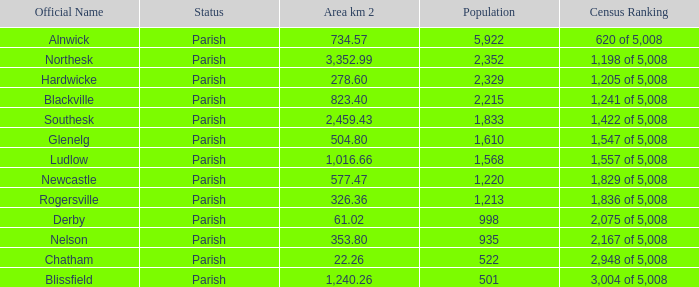Can you tell me the sum of Area km 2 that has the Official Name of glenelg? 504.8. 